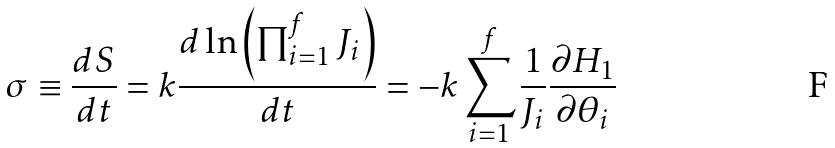<formula> <loc_0><loc_0><loc_500><loc_500>\sigma \equiv \frac { d S } { d t } = k \frac { d \ln \left ( \prod _ { i = 1 } ^ { f } J _ { i } \right ) } { d t } = - k \sum _ { i = 1 } ^ { f } \frac { 1 } { J _ { i } } \frac { \partial H _ { 1 } } { \partial \theta _ { i } }</formula> 